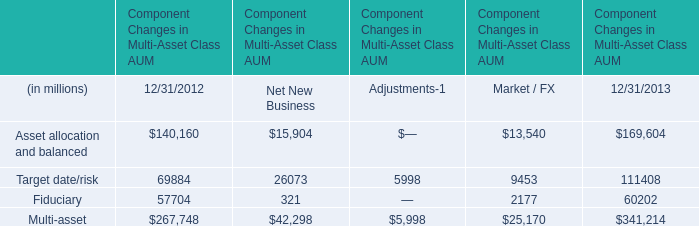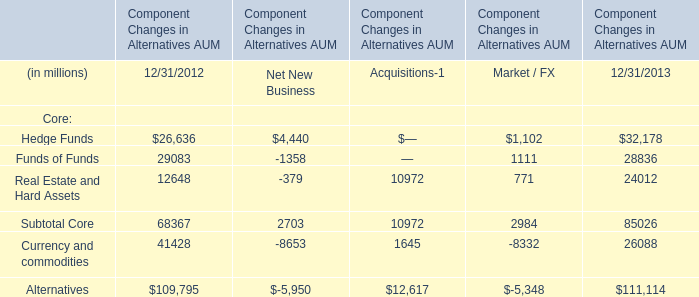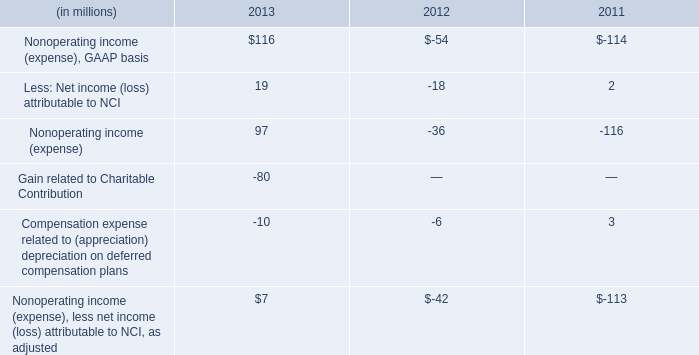In the year with largest amount of Asset allocation and balanced, what's the sum of Net New Business? (in millon) 
Answer: 15904. 